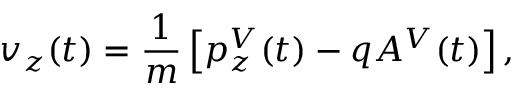Convert formula to latex. <formula><loc_0><loc_0><loc_500><loc_500>v _ { z } ( t ) = \frac { 1 } { m } \left [ p _ { z } ^ { V } ( t ) - q A ^ { V } ( t ) \right ] ,</formula> 